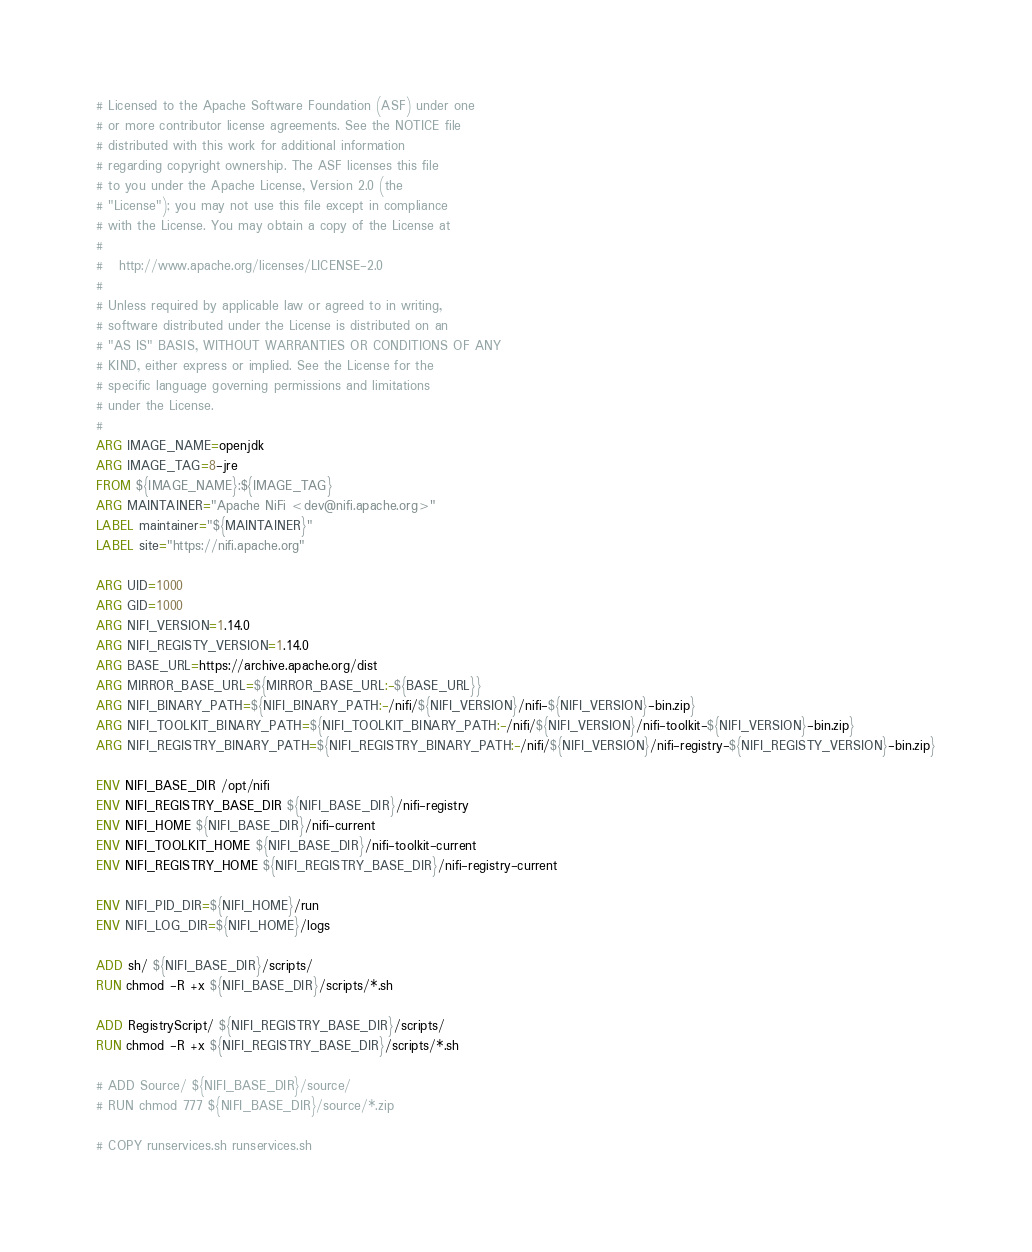Convert code to text. <code><loc_0><loc_0><loc_500><loc_500><_Dockerfile_># Licensed to the Apache Software Foundation (ASF) under one
# or more contributor license agreements. See the NOTICE file
# distributed with this work for additional information
# regarding copyright ownership. The ASF licenses this file
# to you under the Apache License, Version 2.0 (the
# "License"); you may not use this file except in compliance
# with the License. You may obtain a copy of the License at
#
#   http://www.apache.org/licenses/LICENSE-2.0
#
# Unless required by applicable law or agreed to in writing,
# software distributed under the License is distributed on an
# "AS IS" BASIS, WITHOUT WARRANTIES OR CONDITIONS OF ANY
# KIND, either express or implied. See the License for the
# specific language governing permissions and limitations
# under the License.
#
ARG IMAGE_NAME=openjdk
ARG IMAGE_TAG=8-jre
FROM ${IMAGE_NAME}:${IMAGE_TAG}
ARG MAINTAINER="Apache NiFi <dev@nifi.apache.org>"
LABEL maintainer="${MAINTAINER}"
LABEL site="https://nifi.apache.org"

ARG UID=1000
ARG GID=1000
ARG NIFI_VERSION=1.14.0
ARG NIFI_REGISTY_VERSION=1.14.0
ARG BASE_URL=https://archive.apache.org/dist
ARG MIRROR_BASE_URL=${MIRROR_BASE_URL:-${BASE_URL}}
ARG NIFI_BINARY_PATH=${NIFI_BINARY_PATH:-/nifi/${NIFI_VERSION}/nifi-${NIFI_VERSION}-bin.zip}
ARG NIFI_TOOLKIT_BINARY_PATH=${NIFI_TOOLKIT_BINARY_PATH:-/nifi/${NIFI_VERSION}/nifi-toolkit-${NIFI_VERSION}-bin.zip}
ARG NIFI_REGISTRY_BINARY_PATH=${NIFI_REGISTRY_BINARY_PATH:-/nifi/${NIFI_VERSION}/nifi-registry-${NIFI_REGISTY_VERSION}-bin.zip}

ENV NIFI_BASE_DIR /opt/nifi
ENV NIFI_REGISTRY_BASE_DIR ${NIFI_BASE_DIR}/nifi-registry
ENV NIFI_HOME ${NIFI_BASE_DIR}/nifi-current
ENV NIFI_TOOLKIT_HOME ${NIFI_BASE_DIR}/nifi-toolkit-current
ENV NIFI_REGISTRY_HOME ${NIFI_REGISTRY_BASE_DIR}/nifi-registry-current

ENV NIFI_PID_DIR=${NIFI_HOME}/run
ENV NIFI_LOG_DIR=${NIFI_HOME}/logs

ADD sh/ ${NIFI_BASE_DIR}/scripts/
RUN chmod -R +x ${NIFI_BASE_DIR}/scripts/*.sh

ADD RegistryScript/ ${NIFI_REGISTRY_BASE_DIR}/scripts/
RUN chmod -R +x ${NIFI_REGISTRY_BASE_DIR}/scripts/*.sh

# ADD Source/ ${NIFI_BASE_DIR}/source/
# RUN chmod 777 ${NIFI_BASE_DIR}/source/*.zip

# COPY runservices.sh runservices.sh</code> 